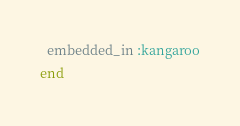<code> <loc_0><loc_0><loc_500><loc_500><_Ruby_>  embedded_in :kangaroo
end
</code> 